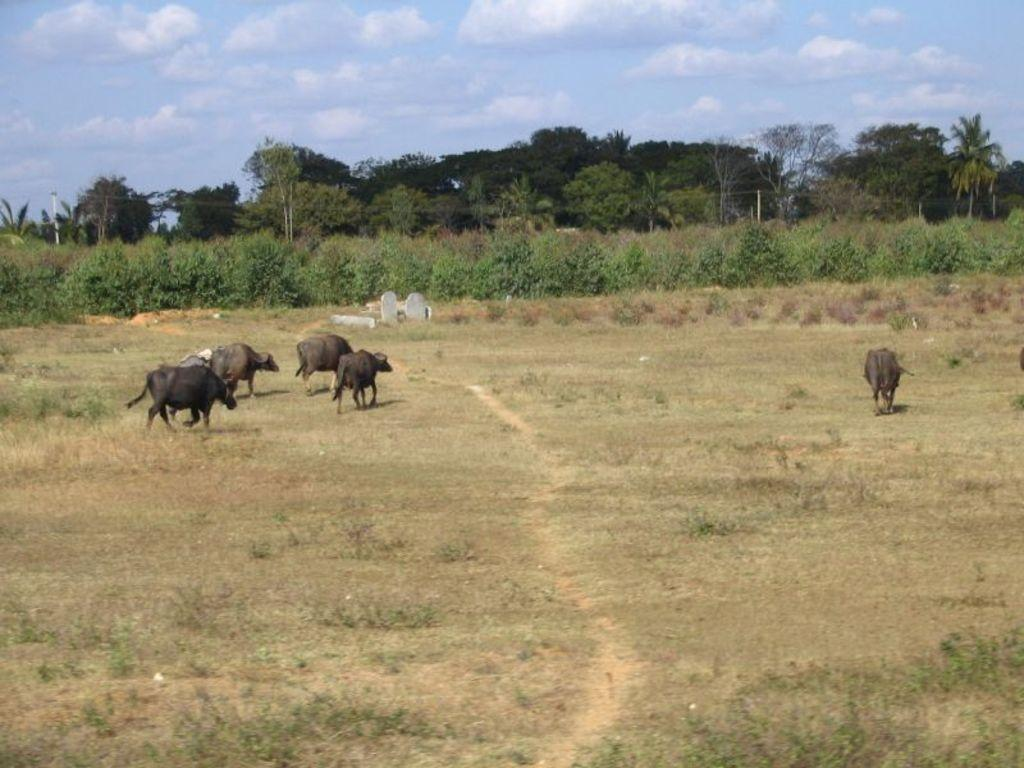What animals can be seen in the image? There are buffaloes in the image. What can be seen in the background of the image? There are rocks, trees, poles, and clouds in the background of the image. What type of lettuce is being served on the glass in the image? There is no lettuce or glass present in the image; it features buffaloes and background elements. 